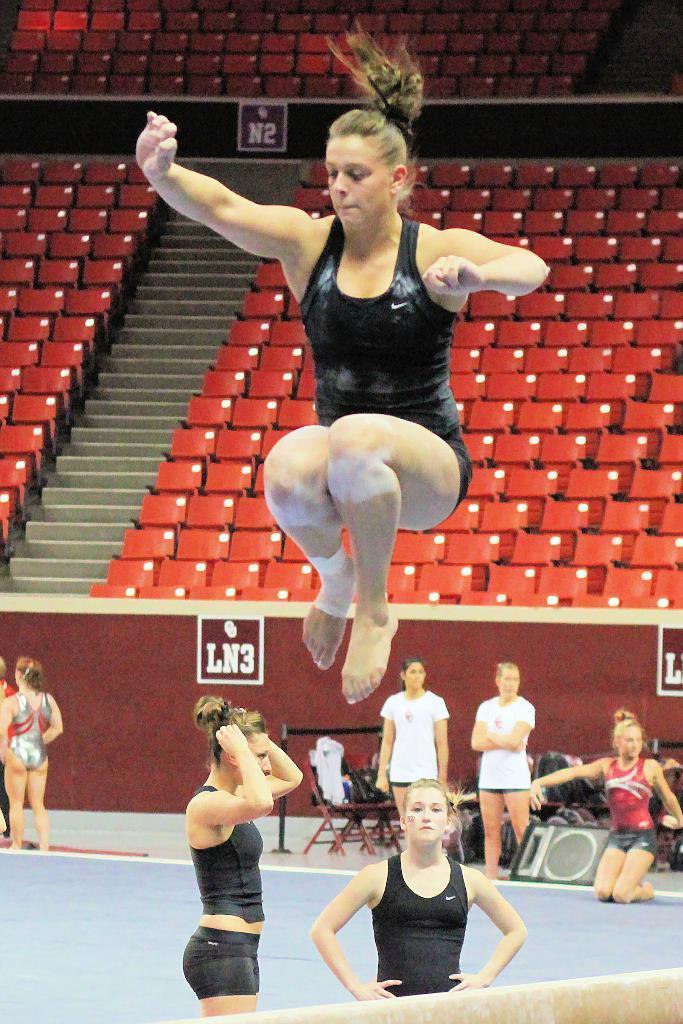Can you describe this image briefly? At the bottom of the image, we can see one object. In the center of the image we can see one woman jumping and two persons are standing. In the background, we can see chairs, fences, banners, bags, one speaker, staircase, few people and a few other objects. 